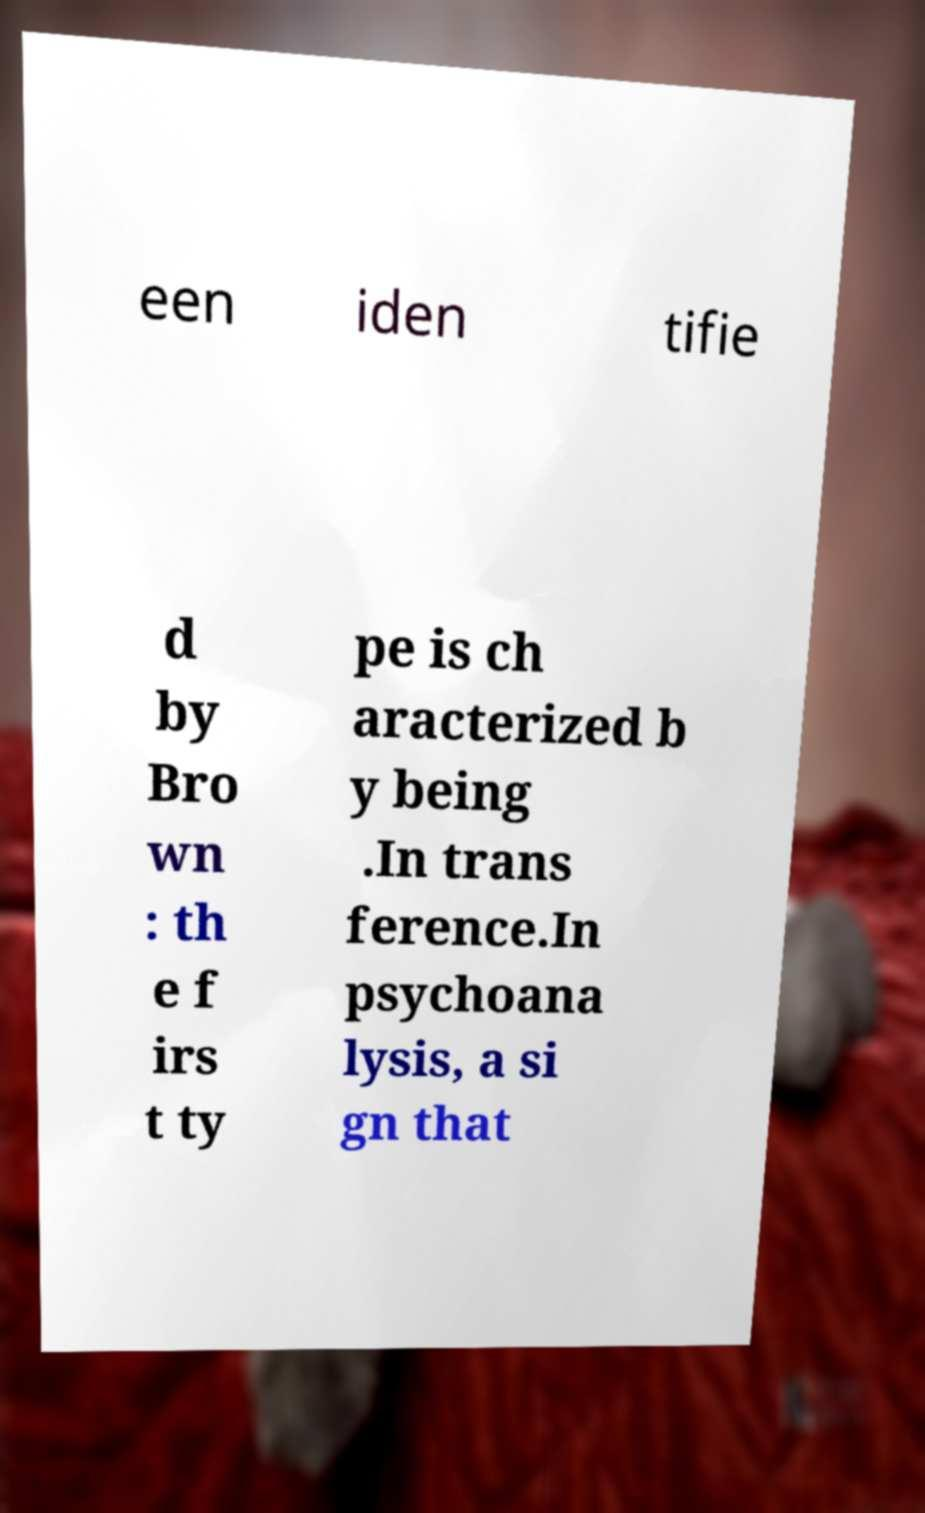Can you accurately transcribe the text from the provided image for me? een iden tifie d by Bro wn : th e f irs t ty pe is ch aracterized b y being .In trans ference.In psychoana lysis, a si gn that 